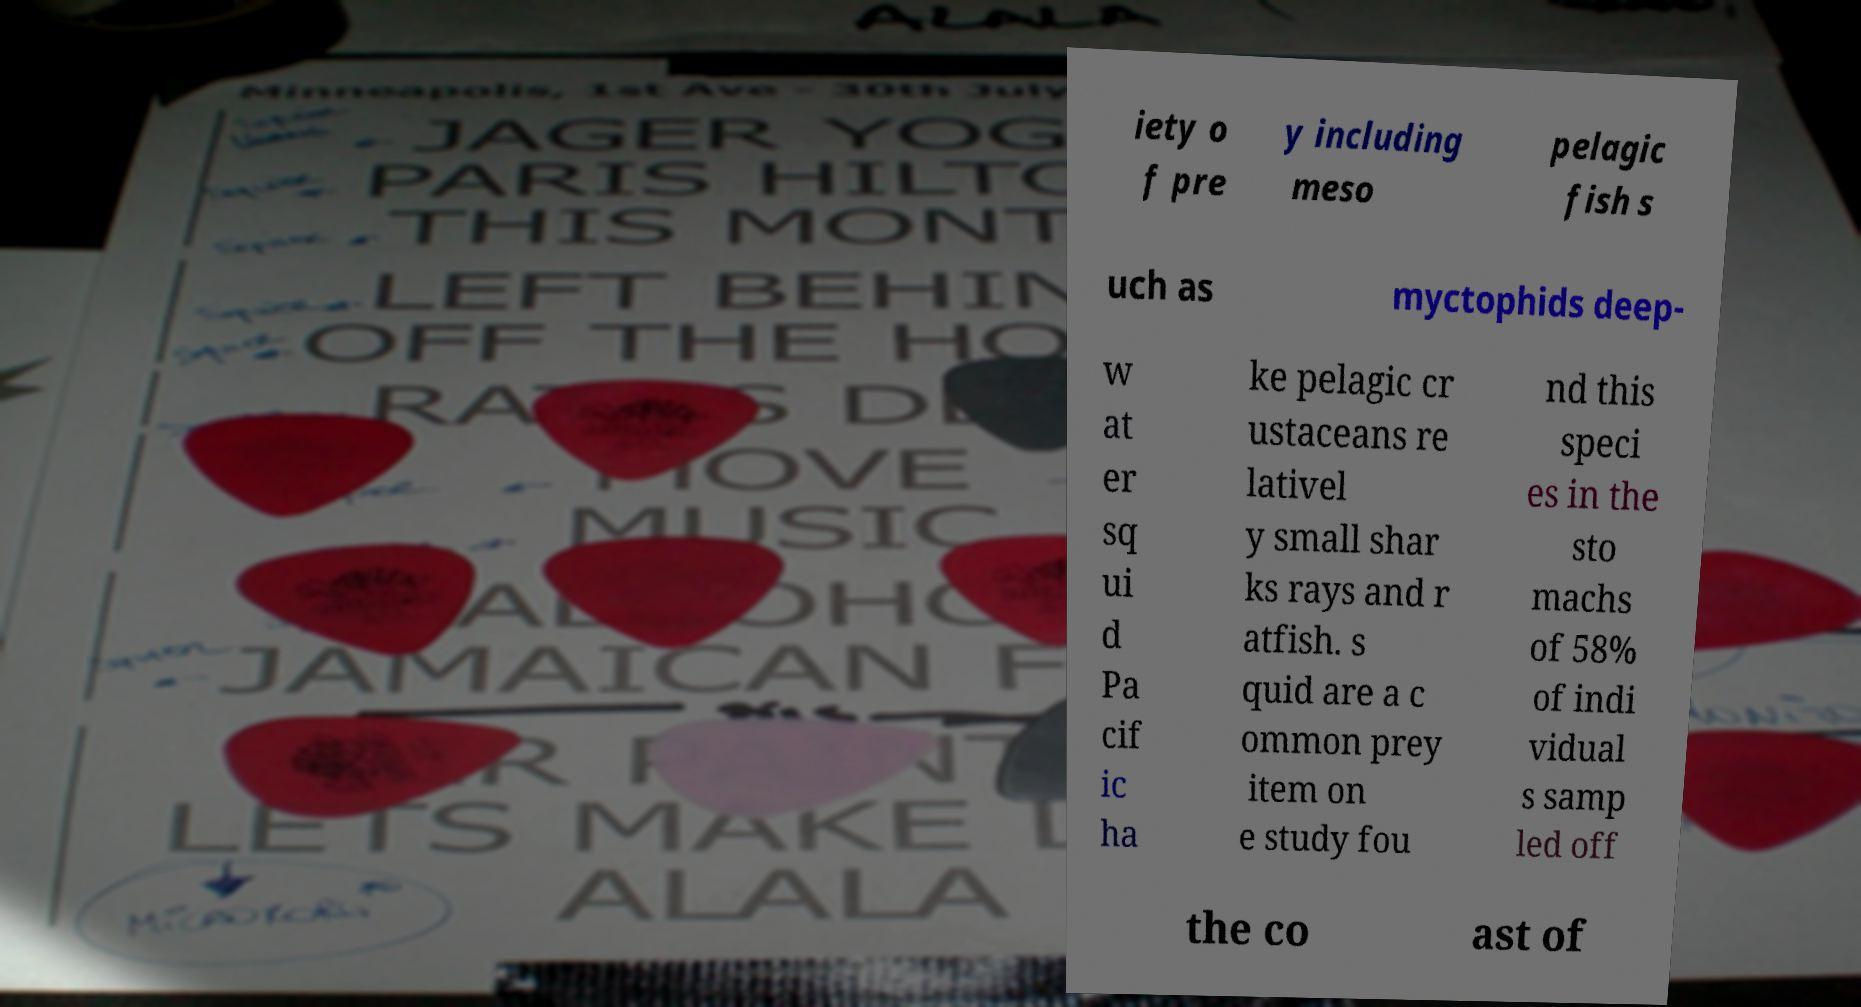Please read and relay the text visible in this image. What does it say? iety o f pre y including meso pelagic fish s uch as myctophids deep- w at er sq ui d Pa cif ic ha ke pelagic cr ustaceans re lativel y small shar ks rays and r atfish. s quid are a c ommon prey item on e study fou nd this speci es in the sto machs of 58% of indi vidual s samp led off the co ast of 